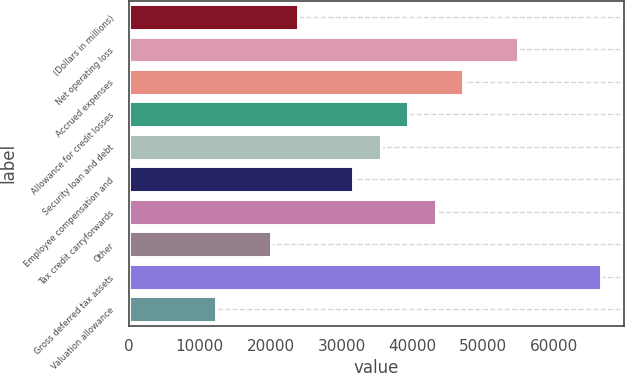Convert chart. <chart><loc_0><loc_0><loc_500><loc_500><bar_chart><fcel>(Dollars in millions)<fcel>Net operating loss<fcel>Accrued expenses<fcel>Allowance for credit losses<fcel>Security loan and debt<fcel>Employee compensation and<fcel>Tax credit carryforwards<fcel>Other<fcel>Gross deferred tax assets<fcel>Valuation allowance<nl><fcel>23916<fcel>54964<fcel>47202<fcel>39440<fcel>35559<fcel>31678<fcel>43321<fcel>20035<fcel>66607<fcel>12273<nl></chart> 